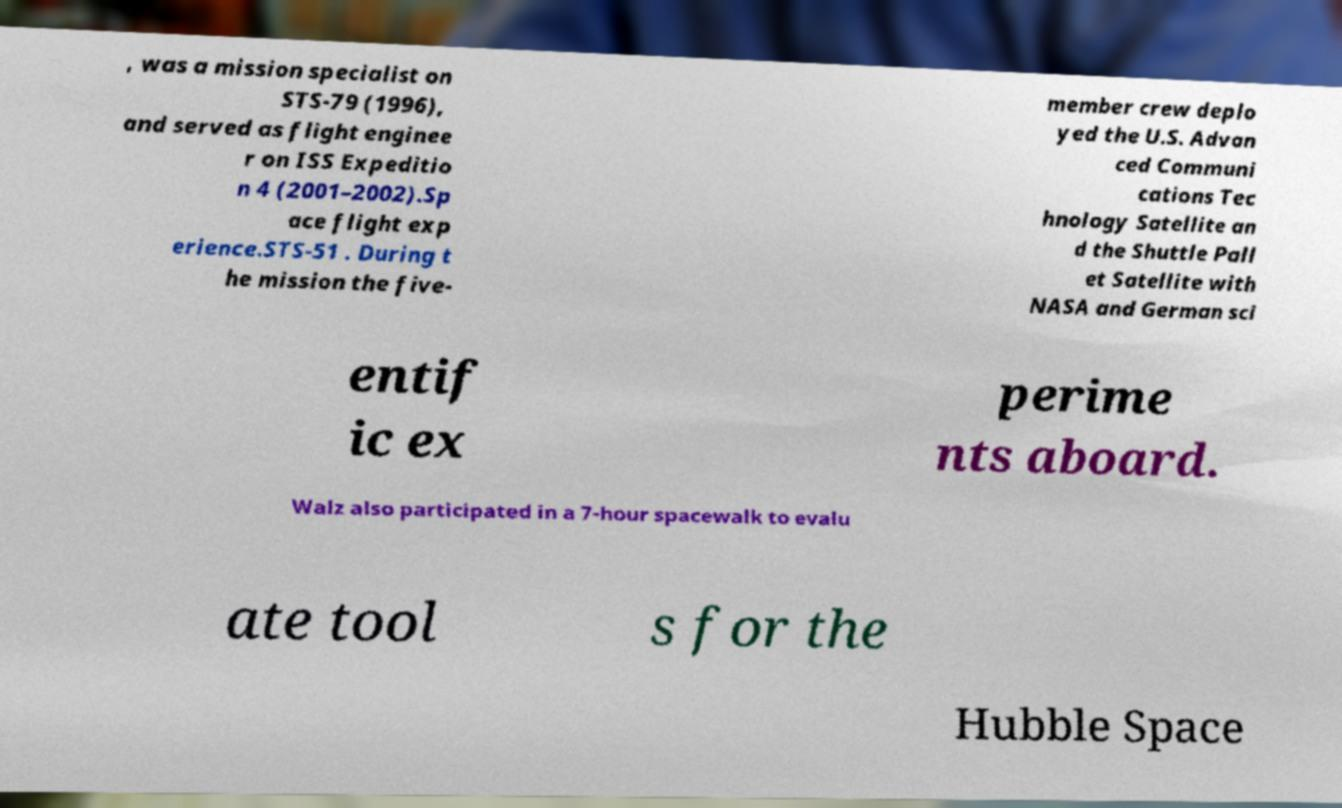Please identify and transcribe the text found in this image. , was a mission specialist on STS-79 (1996), and served as flight enginee r on ISS Expeditio n 4 (2001–2002).Sp ace flight exp erience.STS-51 . During t he mission the five- member crew deplo yed the U.S. Advan ced Communi cations Tec hnology Satellite an d the Shuttle Pall et Satellite with NASA and German sci entif ic ex perime nts aboard. Walz also participated in a 7-hour spacewalk to evalu ate tool s for the Hubble Space 